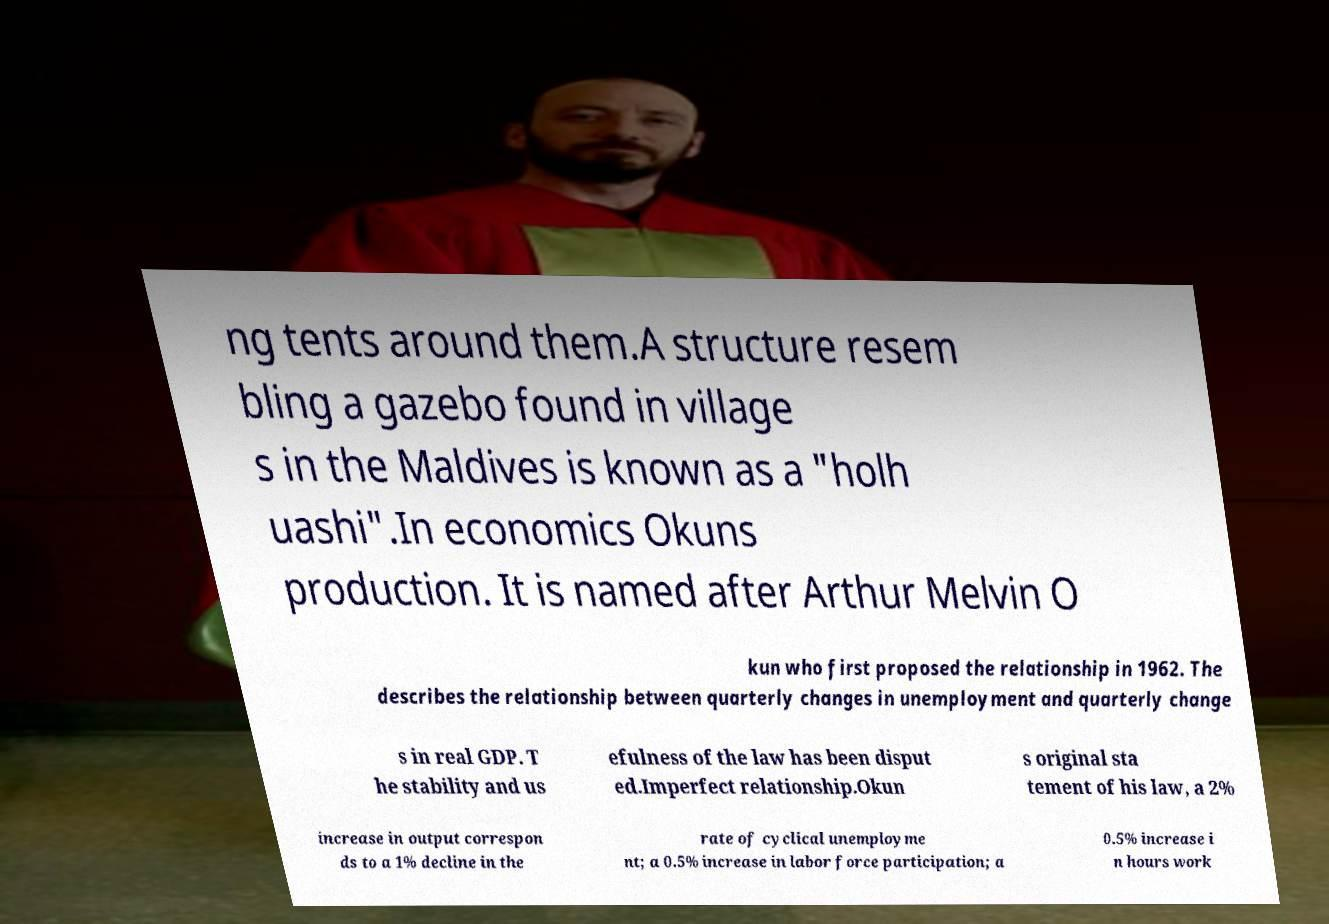Please read and relay the text visible in this image. What does it say? ng tents around them.A structure resem bling a gazebo found in village s in the Maldives is known as a "holh uashi".In economics Okuns production. It is named after Arthur Melvin O kun who first proposed the relationship in 1962. The describes the relationship between quarterly changes in unemployment and quarterly change s in real GDP. T he stability and us efulness of the law has been disput ed.Imperfect relationship.Okun s original sta tement of his law, a 2% increase in output correspon ds to a 1% decline in the rate of cyclical unemployme nt; a 0.5% increase in labor force participation; a 0.5% increase i n hours work 